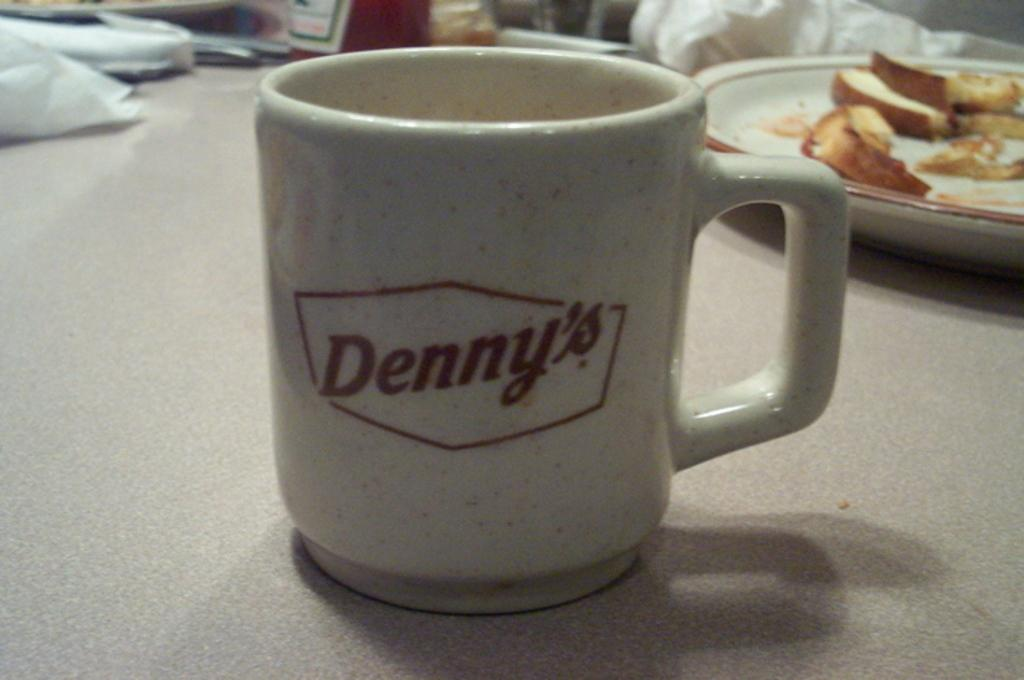<image>
Provide a brief description of the given image. A coffee cup from Denny's sitting on a table. 